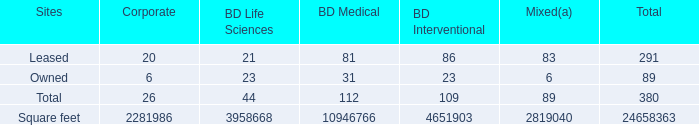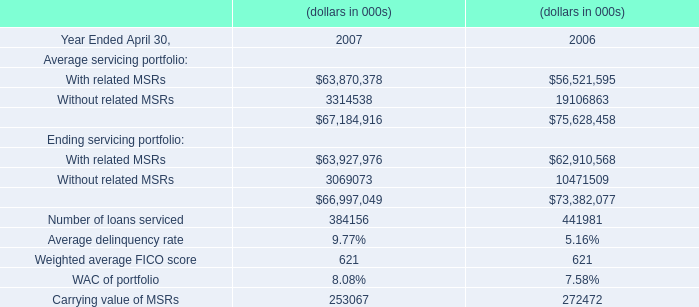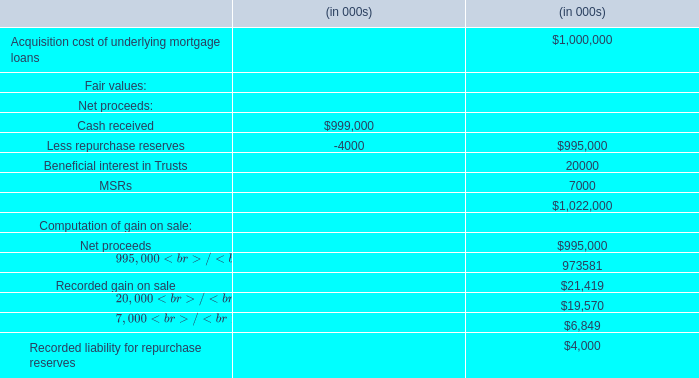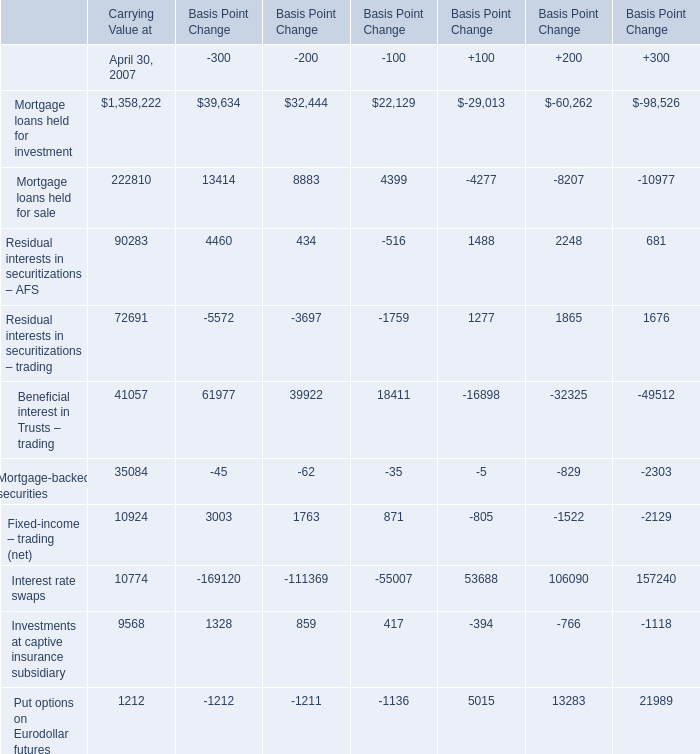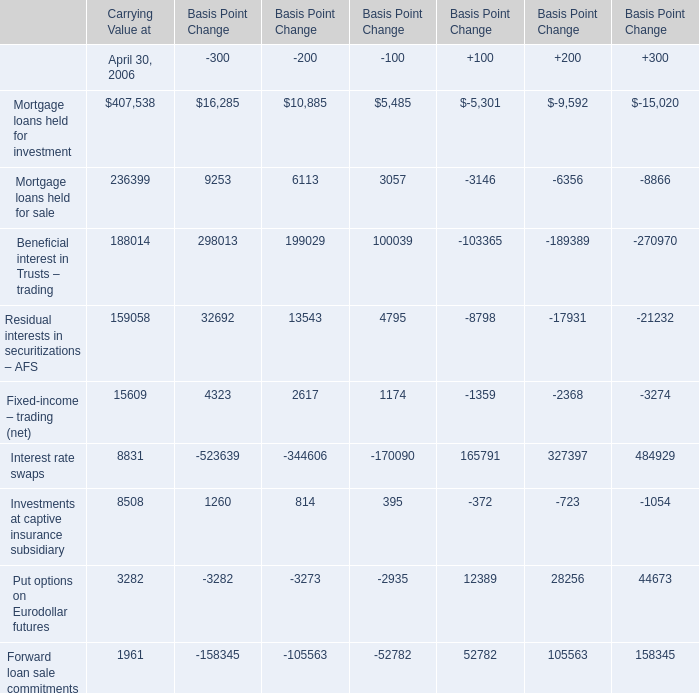What is the sum of Mortgage loans held for sale of Basis Point Change.2, and Residual interests in securitizations – AFS of Basis Point Change.4 ? 
Computations: (4399.0 + 17931.0)
Answer: 22330.0. 